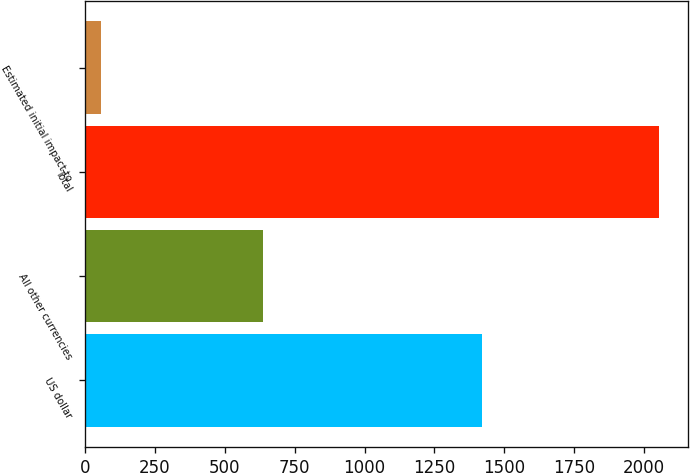<chart> <loc_0><loc_0><loc_500><loc_500><bar_chart><fcel>US dollar<fcel>All other currencies<fcel>Total<fcel>Estimated initial impact to<nl><fcel>1419<fcel>635<fcel>2054<fcel>57<nl></chart> 